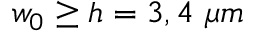Convert formula to latex. <formula><loc_0><loc_0><loc_500><loc_500>w _ { 0 } \geq h = 3 , 4 \mu m</formula> 